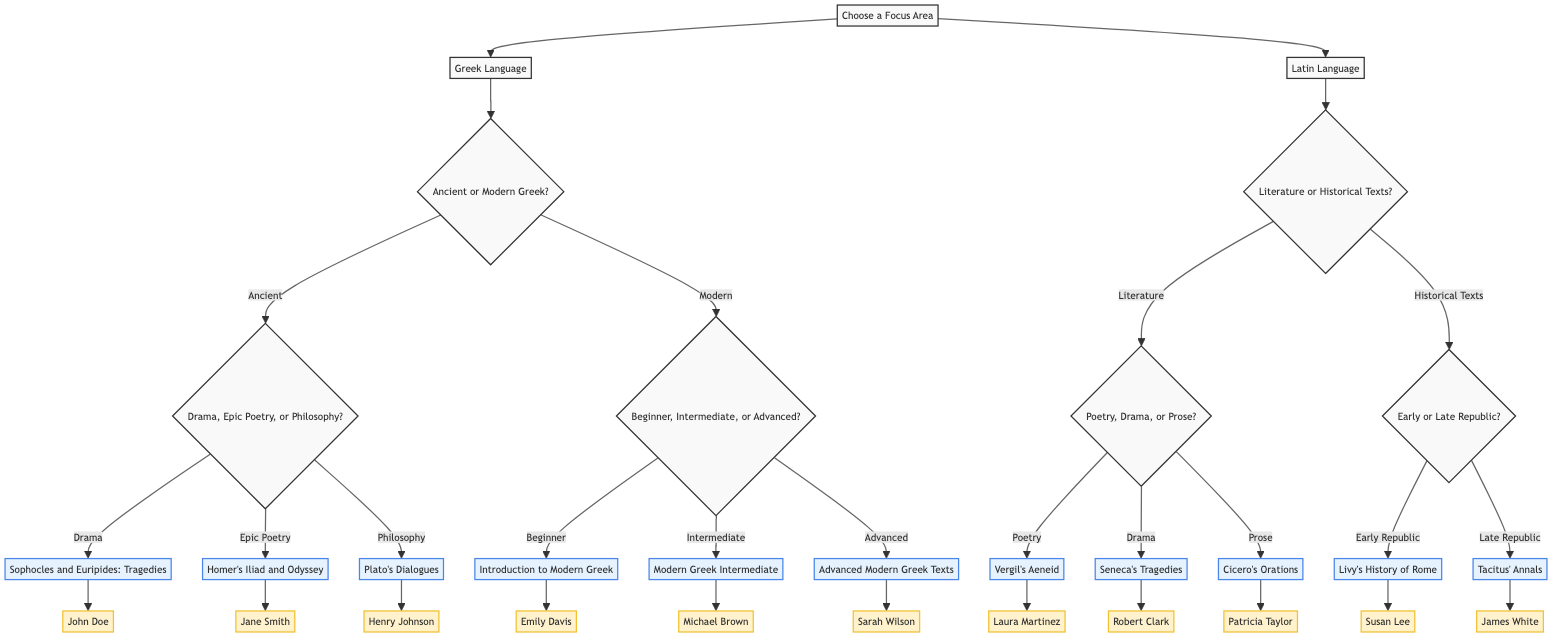What are the two main focus areas in the diagram? The diagram starts with the node "Choose a Focus Area", which branches into two options: "Greek Language" and "Latin Language". These are the primary focus areas the diagram presents.
Answer: Greek Language, Latin Language How many courses are offered under the Latin Language? Within the "Latin Language" node, it has two main branches: "Literature" and "Historical Texts". Each of these has two additional courses, resulting in a total of four courses under Latin Language.
Answer: 4 What is the course associated with Drama in Ancient Greek? In the diagram, focusing on "Greek Language" and then selecting "Ancient Greek", the path leads to the node "Drama", which points to the course "Sophocles and Euripides: Tragedies".
Answer: Sophocles and Euripides: Tragedies Who teaches the course on Cicero's Orations? Following the path from "Latin Language" to "Literature", and then to "Prose", leads to the specific course "Cicero's Orations". The diagram indicates that this course is taught by "Patricia Taylor".
Answer: Patricia Taylor If a student selects Modern Greek and is at an advanced level, which course will they take? By selecting "Modern Greek" and then choosing "Advanced" as the skill level, the course that follows is "Advanced Modern Greek Texts".
Answer: Advanced Modern Greek Texts What criteria are used to choose a course in Latin Language focused on literature? For the "Latin Language" under the "Literature" section, the criteria presented are "Are you interested in poetry, drama, or prose?" This question determines the specific literary focus before selecting a course.
Answer: Poetry, Drama, Prose Which professor is associated with the course "Livy’s History of Rome"? Following the decision path of "Latin Language" to "Historical Texts" and then selecting "Early Republic", leads to the course "Livy’s History of Rome", which is instructed by "Susan Lee."
Answer: Susan Lee How many criteria are presented for selecting courses in Modern Greek? The "Modern Greek" selection provides one main criterion: "Are you a beginner, intermediate, or advanced student?" Under this main branch, there are three options detailing the skill level. Therefore, there is one main criterion leading to three choices.
Answer: 1 What is the relationship between "Philosophy" and "Plato’s Dialogues"? In the flow of the decision tree, selecting "Greek Language", choosing "Ancient Greek", and then "Philosophy" leads directly to "Plato’s Dialogues", establishing that "Philosophy" is a category under which this specific course is listed.
Answer: Category Relationship 